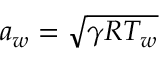Convert formula to latex. <formula><loc_0><loc_0><loc_500><loc_500>a _ { w } = \sqrt { \gamma R T _ { w } }</formula> 